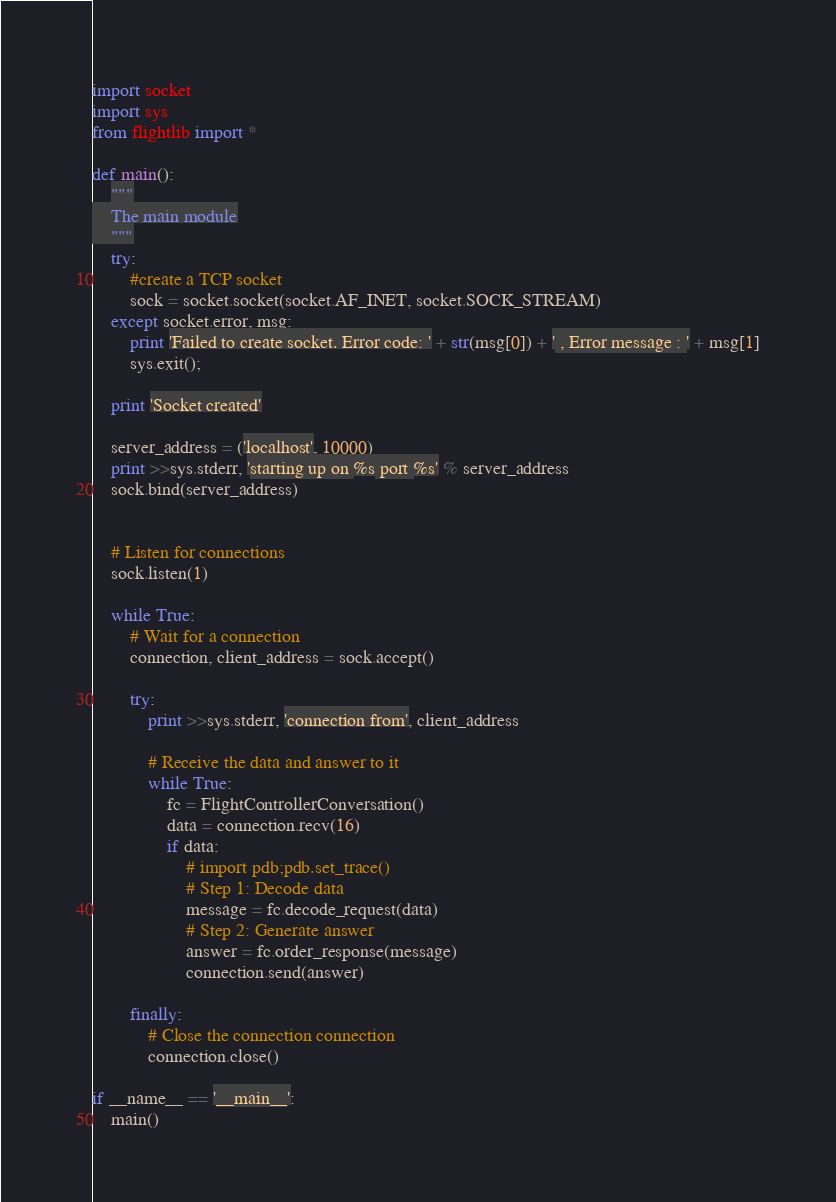Convert code to text. <code><loc_0><loc_0><loc_500><loc_500><_Python_>import socket
import sys
from flightlib import *

def main():
    """
    The main module
    """
    try:
        #create a TCP socket
        sock = socket.socket(socket.AF_INET, socket.SOCK_STREAM)
    except socket.error, msg:
        print 'Failed to create socket. Error code: ' + str(msg[0]) + ' , Error message : ' + msg[1]
        sys.exit();
    
    print 'Socket created'

    server_address = ('localhost', 10000)
    print >>sys.stderr, 'starting up on %s port %s' % server_address
    sock.bind(server_address)


    # Listen for connections
    sock.listen(1)

    while True:
        # Wait for a connection
        connection, client_address = sock.accept()

        try:
            print >>sys.stderr, 'connection from', client_address

            # Receive the data and answer to it
            while True:
                fc = FlightControllerConversation()
                data = connection.recv(16)
                if data:
                    # import pdb;pdb.set_trace()
                    # Step 1: Decode data
                    message = fc.decode_request(data)
                    # Step 2: Generate answer
                    answer = fc.order_response(message)
                    connection.send(answer)
                
        finally:
            # Close the connection connection
            connection.close()

if __name__ == '__main__':
    main()</code> 